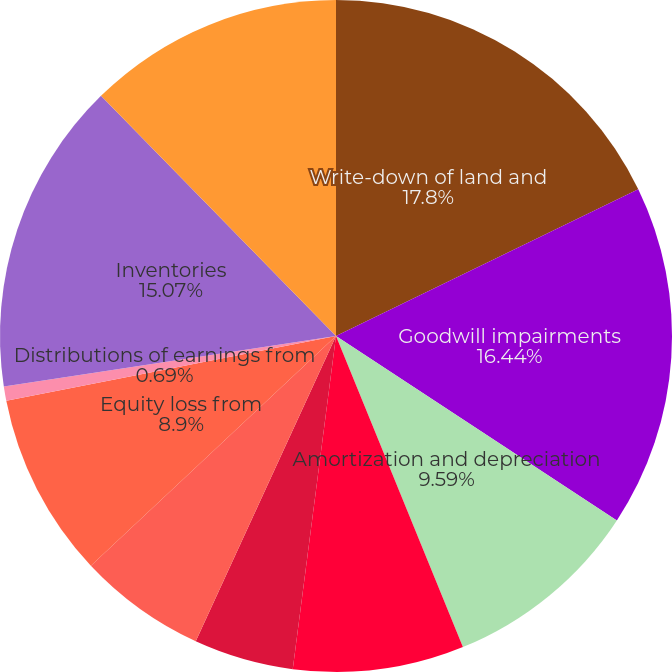Convert chart. <chart><loc_0><loc_0><loc_500><loc_500><pie_chart><fcel>Write-down of land and<fcel>Goodwill impairments<fcel>Amortization and depreciation<fcel>Stock-based compensation<fcel>Loss (gain) on debt<fcel>Deferred income taxes<fcel>Equity loss from<fcel>Distributions of earnings from<fcel>Inventories<fcel>Residential mortgage loans<nl><fcel>17.81%<fcel>16.44%<fcel>9.59%<fcel>8.22%<fcel>4.8%<fcel>6.16%<fcel>8.9%<fcel>0.69%<fcel>15.07%<fcel>12.33%<nl></chart> 